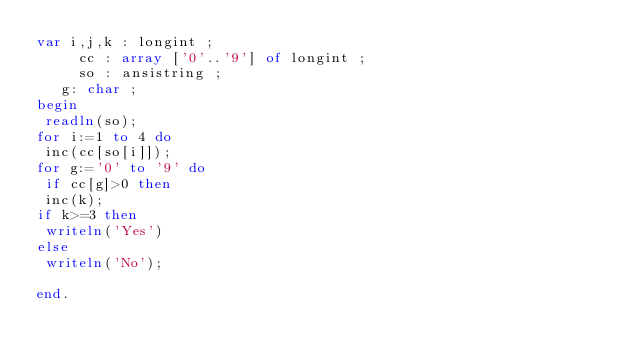Convert code to text. <code><loc_0><loc_0><loc_500><loc_500><_Pascal_>var i,j,k : longint ;
     cc : array ['0'..'9'] of longint ;
     so : ansistring ;
   g: char ;
begin
 readln(so);
for i:=1 to 4 do
 inc(cc[so[i]]);
for g:='0' to '9' do
 if cc[g]>0 then
 inc(k);
if k>=3 then
 writeln('Yes')
else
 writeln('No');

end.</code> 